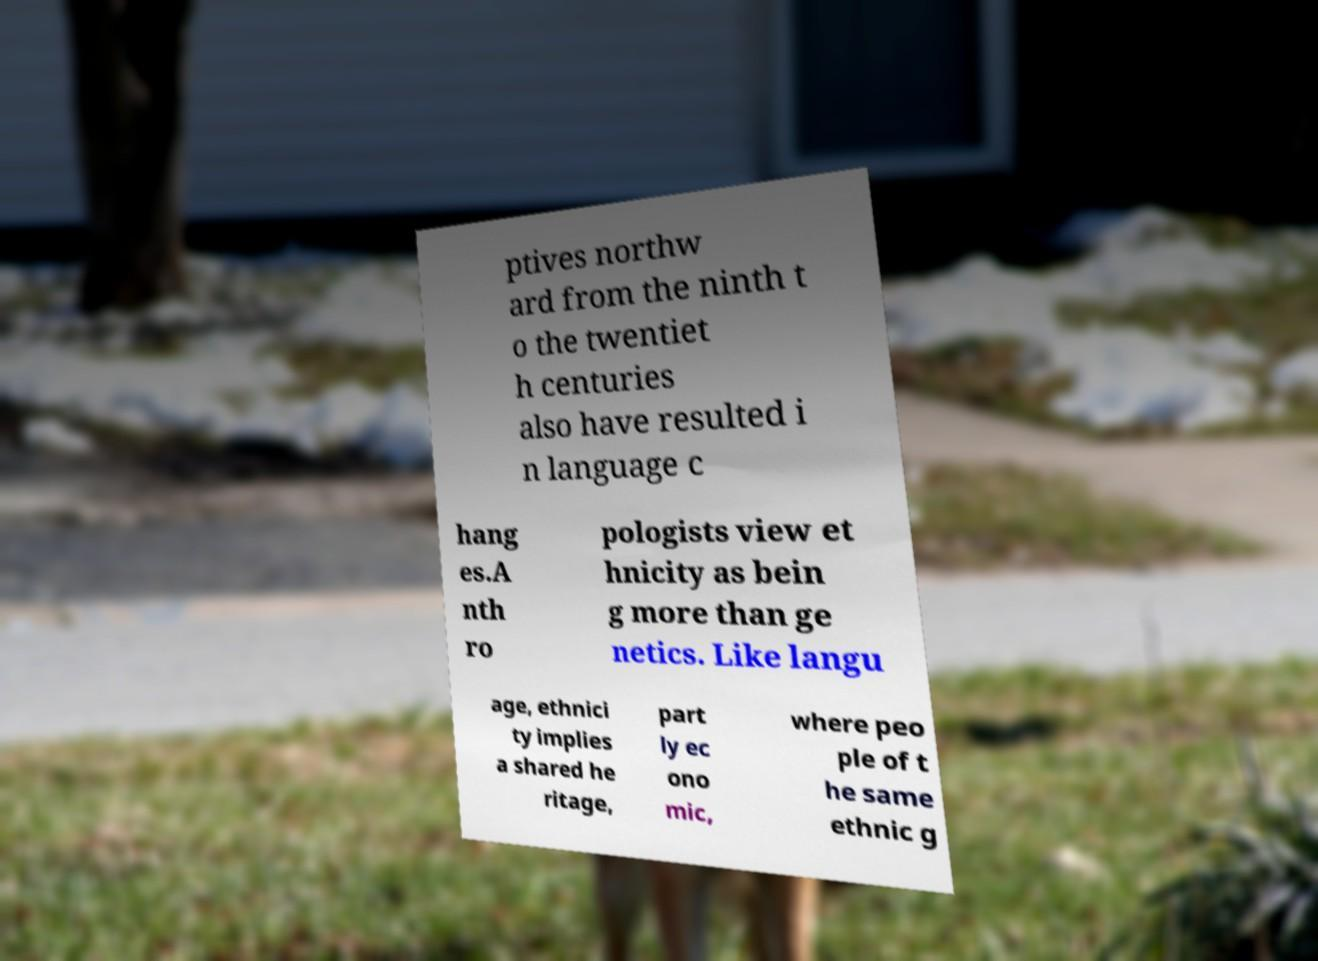Please identify and transcribe the text found in this image. ptives northw ard from the ninth t o the twentiet h centuries also have resulted i n language c hang es.A nth ro pologists view et hnicity as bein g more than ge netics. Like langu age, ethnici ty implies a shared he ritage, part ly ec ono mic, where peo ple of t he same ethnic g 